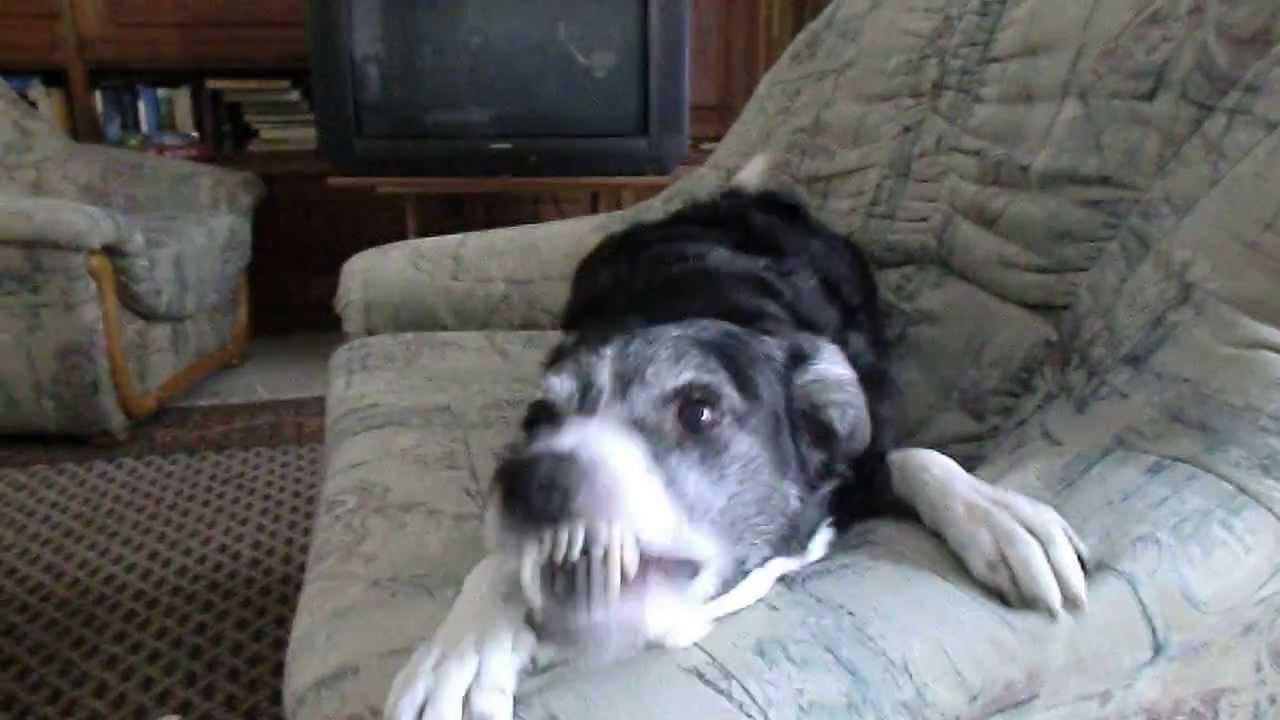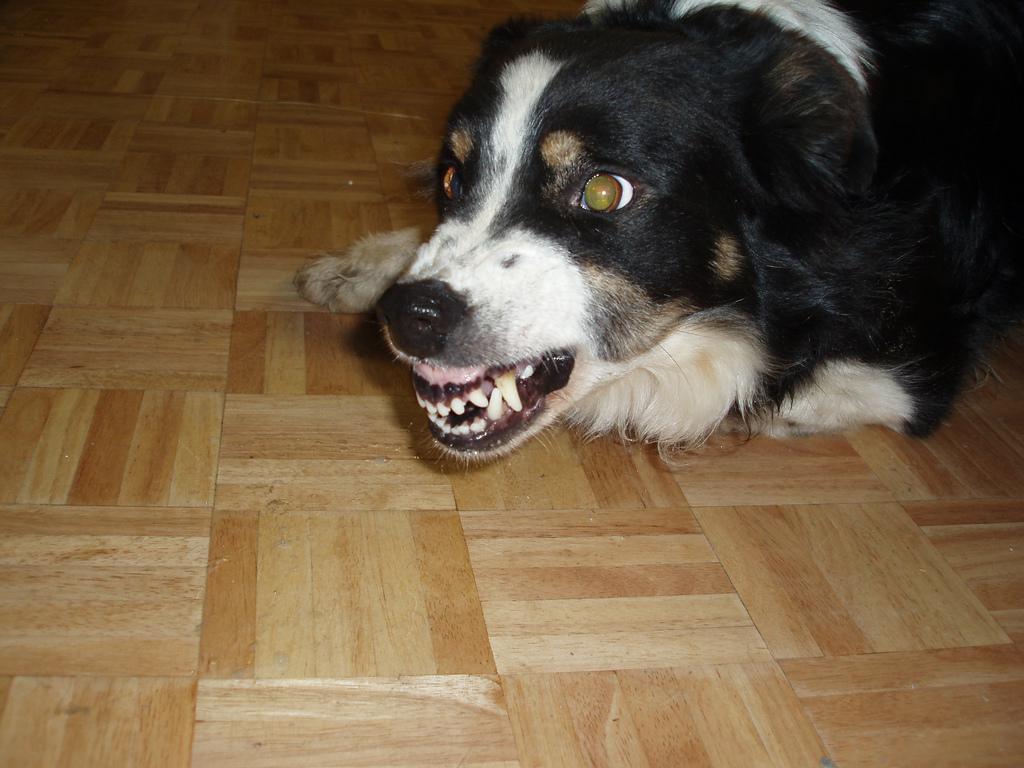The first image is the image on the left, the second image is the image on the right. Given the left and right images, does the statement "Each image shows an angry-looking dog baring its fangs, and the dogs in the images face the same general direction." hold true? Answer yes or no. Yes. The first image is the image on the left, the second image is the image on the right. Examine the images to the left and right. Is the description "Both dogs are barring their teeth in aggression." accurate? Answer yes or no. Yes. 